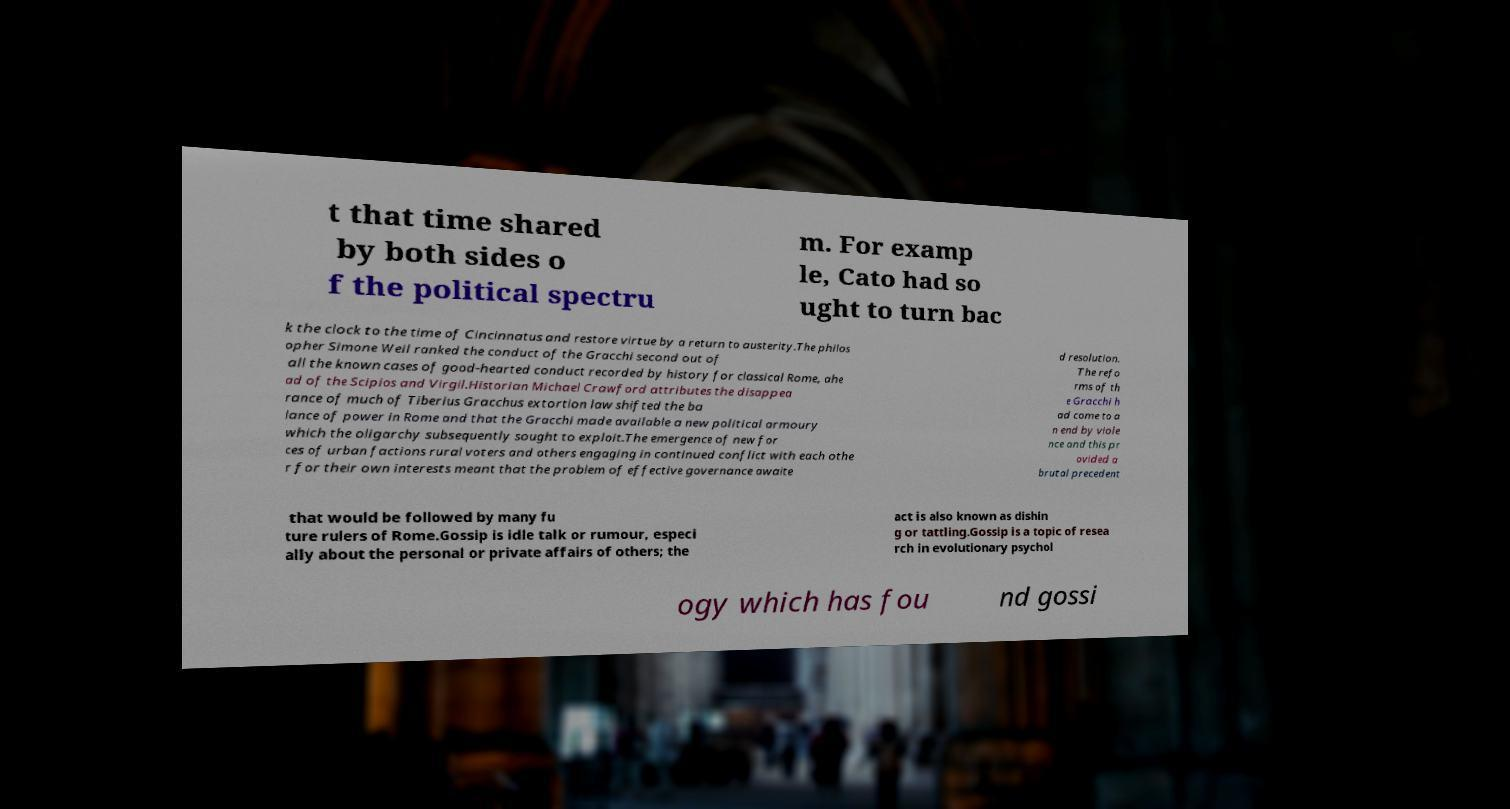Could you assist in decoding the text presented in this image and type it out clearly? t that time shared by both sides o f the political spectru m. For examp le, Cato had so ught to turn bac k the clock to the time of Cincinnatus and restore virtue by a return to austerity.The philos opher Simone Weil ranked the conduct of the Gracchi second out of all the known cases of good-hearted conduct recorded by history for classical Rome, ahe ad of the Scipios and Virgil.Historian Michael Crawford attributes the disappea rance of much of Tiberius Gracchus extortion law shifted the ba lance of power in Rome and that the Gracchi made available a new political armoury which the oligarchy subsequently sought to exploit.The emergence of new for ces of urban factions rural voters and others engaging in continued conflict with each othe r for their own interests meant that the problem of effective governance awaite d resolution. The refo rms of th e Gracchi h ad come to a n end by viole nce and this pr ovided a brutal precedent that would be followed by many fu ture rulers of Rome.Gossip is idle talk or rumour, especi ally about the personal or private affairs of others; the act is also known as dishin g or tattling.Gossip is a topic of resea rch in evolutionary psychol ogy which has fou nd gossi 